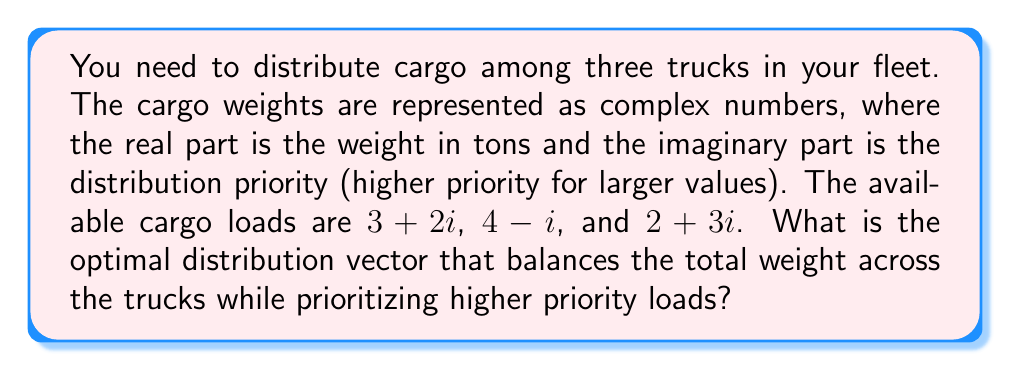Could you help me with this problem? Let's approach this step-by-step:

1) First, we need to sum up all the cargo loads to get the total:
   $$(3+2i) + (4-i) + (2+3i) = 9+4i$$

2) To balance the load, we want to distribute this evenly among the three trucks. So, we divide the total by 3:
   $$\frac{9+4i}{3} = 3+\frac{4}{3}i$$

3) This gives us the ideal load for each truck. Now, we need to assign the actual cargo loads to minimize the difference from this ideal.

4) Let's represent our distribution as a vector $\vec{v} = (v_1, v_2, v_3)$, where each component represents which truck (1, 2, or 3) each cargo load goes to.

5) We want to minimize:
   $$|(3+2i)v_1 + (4-i)v_2 + (2+3i)v_3 - (3+\frac{4}{3}i)|$$

6) Considering the priorities (imaginary parts), we should assign the highest priority load $(2+3i)$ to one truck, the next highest $(3+2i)$ to another, and the lowest $(4-i)$ to the third.

7) The optimal distribution that balances weight and priority is:
   $\vec{v} = (2, 3, 1)$

   This means:
   - Truck 1 gets the $(3+2i)$ load
   - Truck 2 gets the $(4-i)$ load
   - Truck 3 gets the $(2+3i)$ load

8) We can verify:
   Truck 1: $3+2i$
   Truck 2: $4-i$
   Truck 3: $2+3i$

   Each truck has a load close to the ideal $3+\frac{4}{3}i$, with higher priority loads on separate trucks.
Answer: $(2, 3, 1)$ 